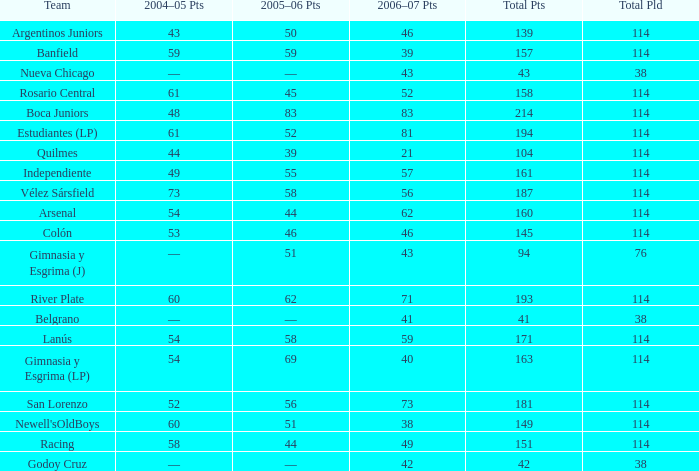What is the total pld with 158 points in 2006-07, and less than 52 points in 2006-07? None. 